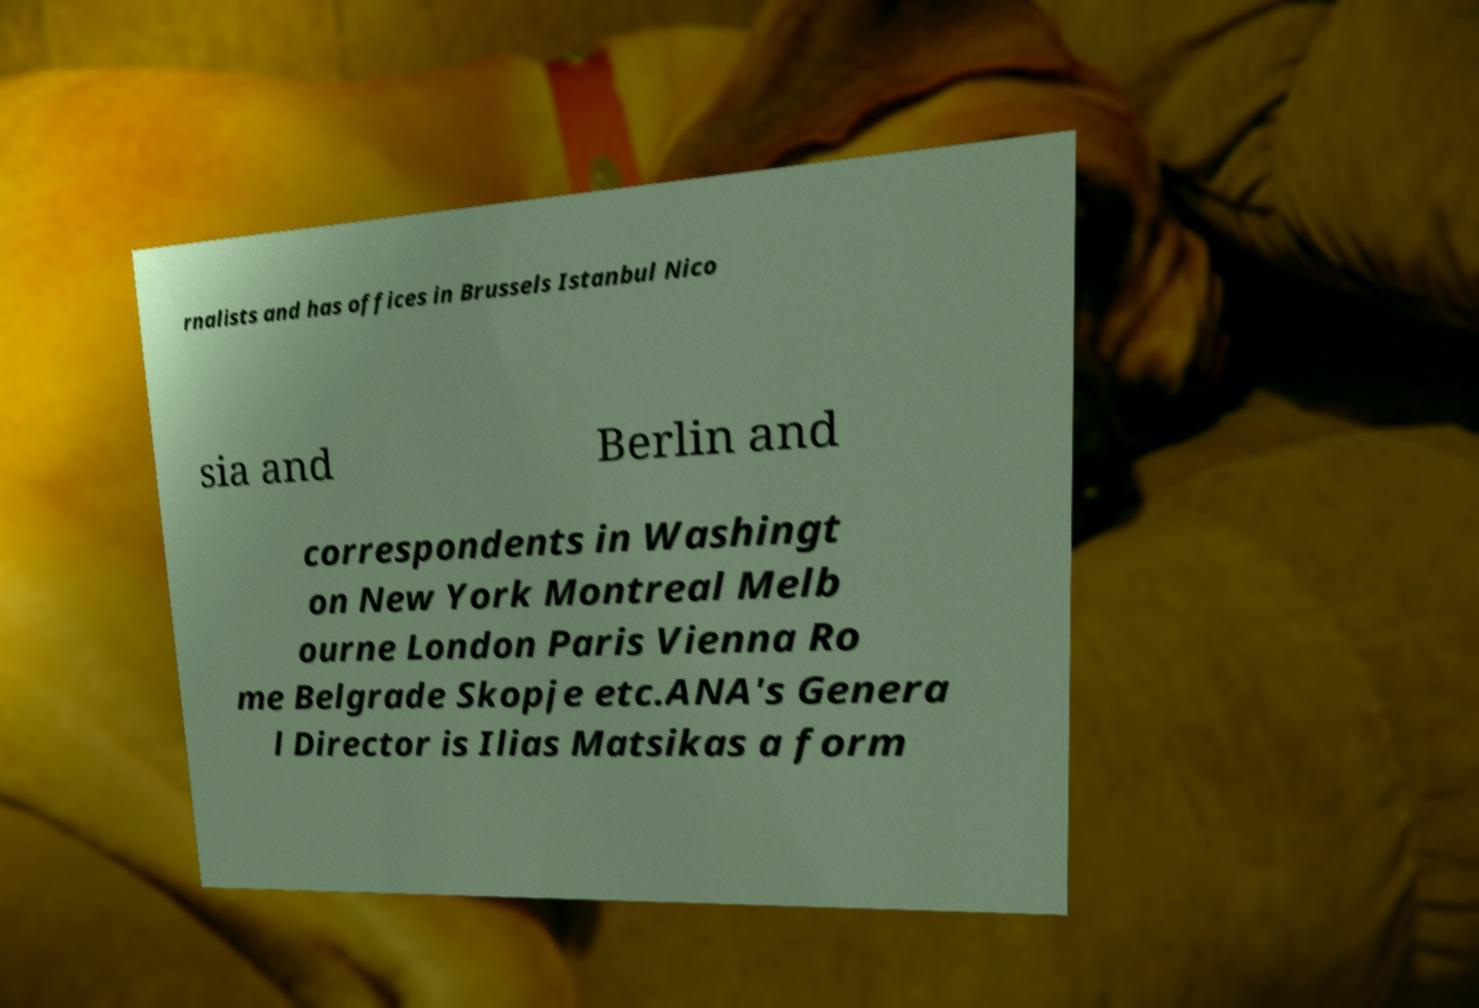Can you read and provide the text displayed in the image?This photo seems to have some interesting text. Can you extract and type it out for me? rnalists and has offices in Brussels Istanbul Nico sia and Berlin and correspondents in Washingt on New York Montreal Melb ourne London Paris Vienna Ro me Belgrade Skopje etc.ANA's Genera l Director is Ilias Matsikas a form 